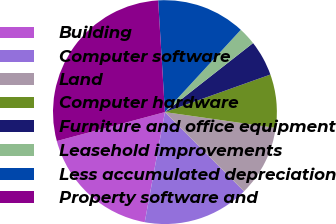Convert chart to OTSL. <chart><loc_0><loc_0><loc_500><loc_500><pie_chart><fcel>Building<fcel>Computer software<fcel>Land<fcel>Computer hardware<fcel>Furniture and office equipment<fcel>Leasehold improvements<fcel>Less accumulated depreciation<fcel>Property software and<nl><fcel>17.95%<fcel>15.38%<fcel>10.26%<fcel>7.7%<fcel>5.13%<fcel>2.57%<fcel>12.82%<fcel>28.2%<nl></chart> 